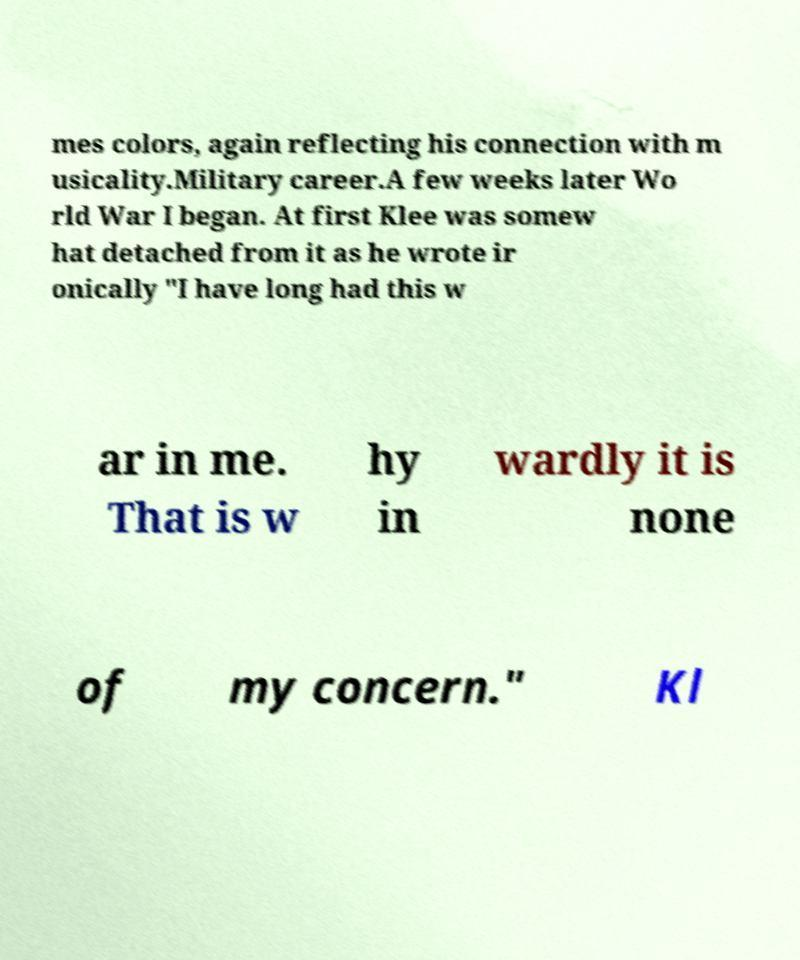Please read and relay the text visible in this image. What does it say? mes colors, again reflecting his connection with m usicality.Military career.A few weeks later Wo rld War I began. At first Klee was somew hat detached from it as he wrote ir onically "I have long had this w ar in me. That is w hy in wardly it is none of my concern." Kl 